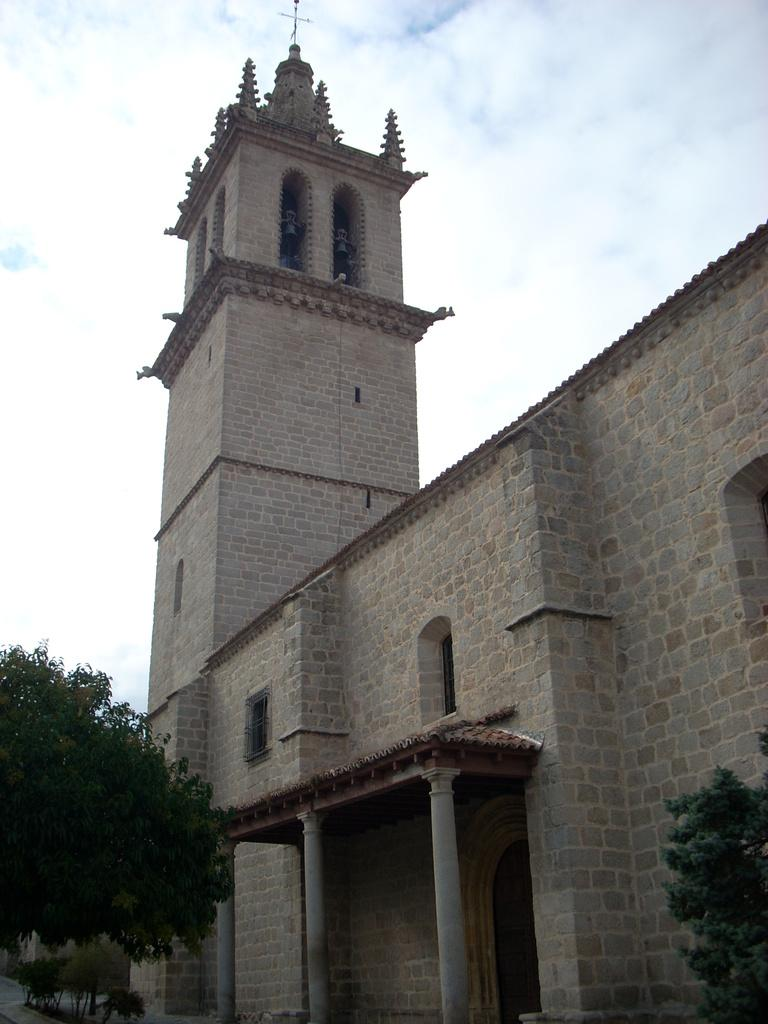What type of natural elements are present at the bottom of the image? There are trees and plants at the bottom of the image. What type of man-made structure can be seen in the background? There is a building in the background of the image. What feature of the building is mentioned in the facts? The building has windows. What symbol is present on the building? There is a cross symbol on the building. What is visible in the sky in the image? Clouds are visible in the sky. How many friends are sitting on the brass bench in the image? There is no brass bench or friends present in the image. 